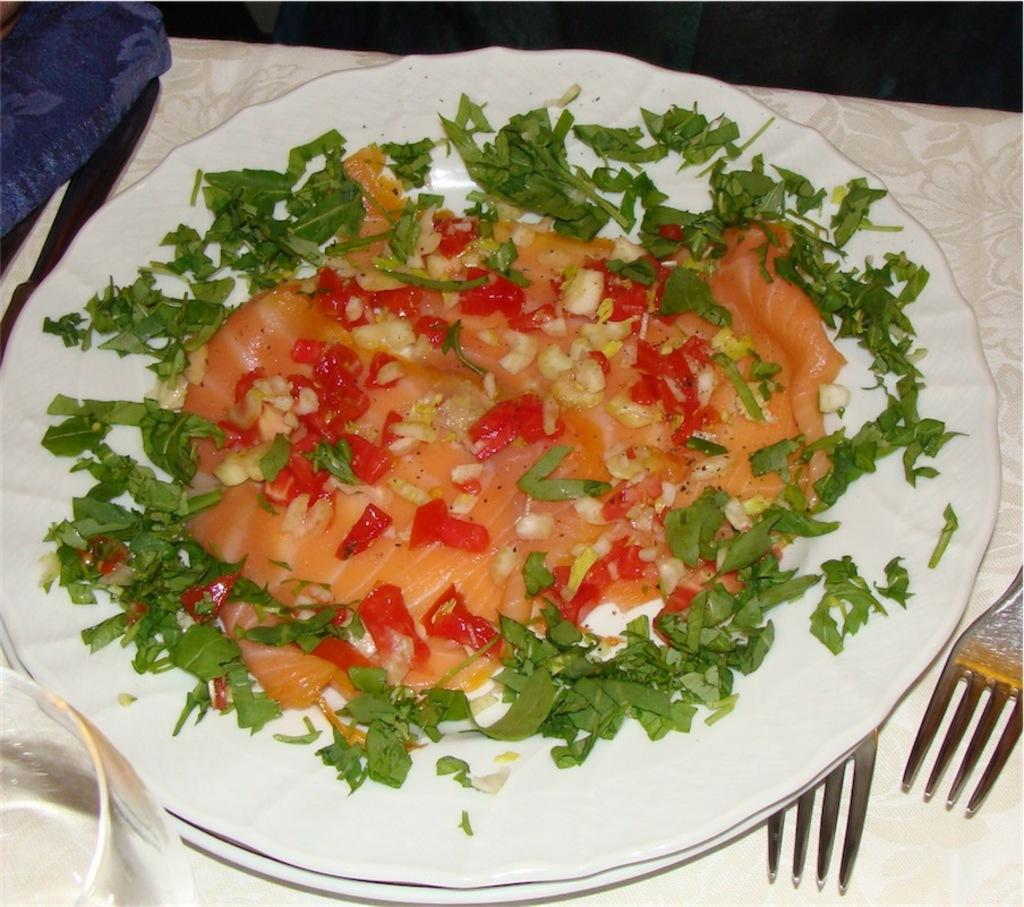What is placed on the white plate in the image? There is an edible placed on a white plate in the image. What can be seen in the left corner of the image? There is a glass in the left corner of the image. What utensils are visible in the right corner of the image? There are two forks in the right corner of the image. What type of silk is being used for the activity in the image? There is no silk or activity present in the image. Can you hear any sounds coming from the image? The image is silent, and there are no sounds to be heard. 